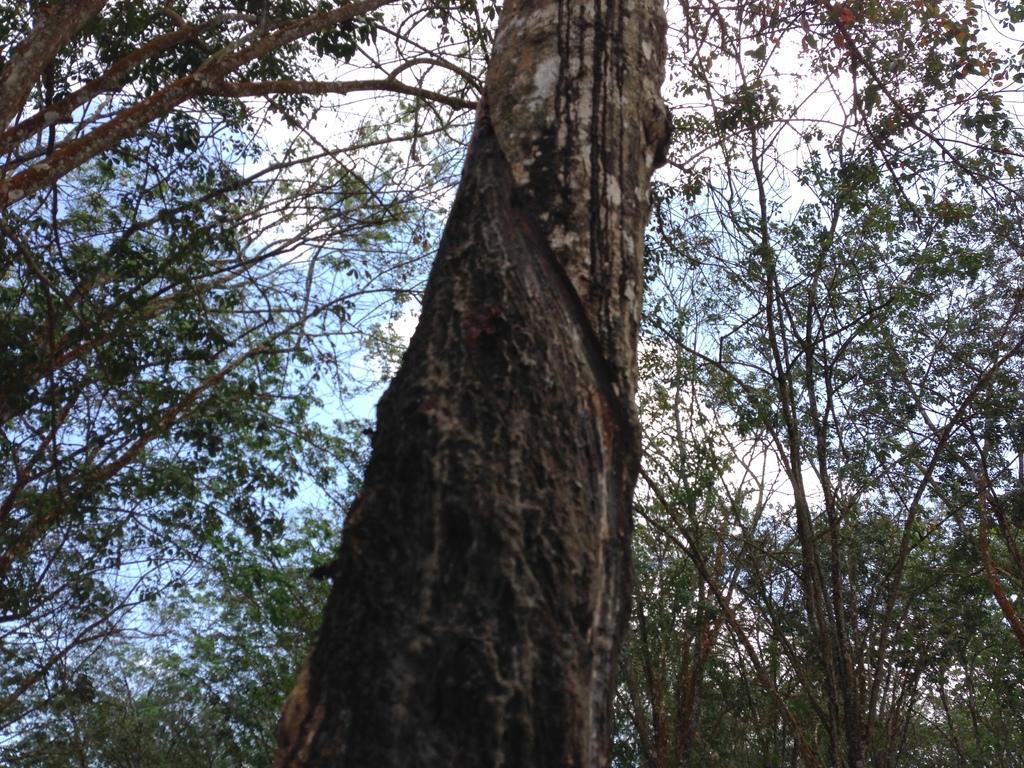How would you summarize this image in a sentence or two? In this image there are some trees, and in the background there is sky. 